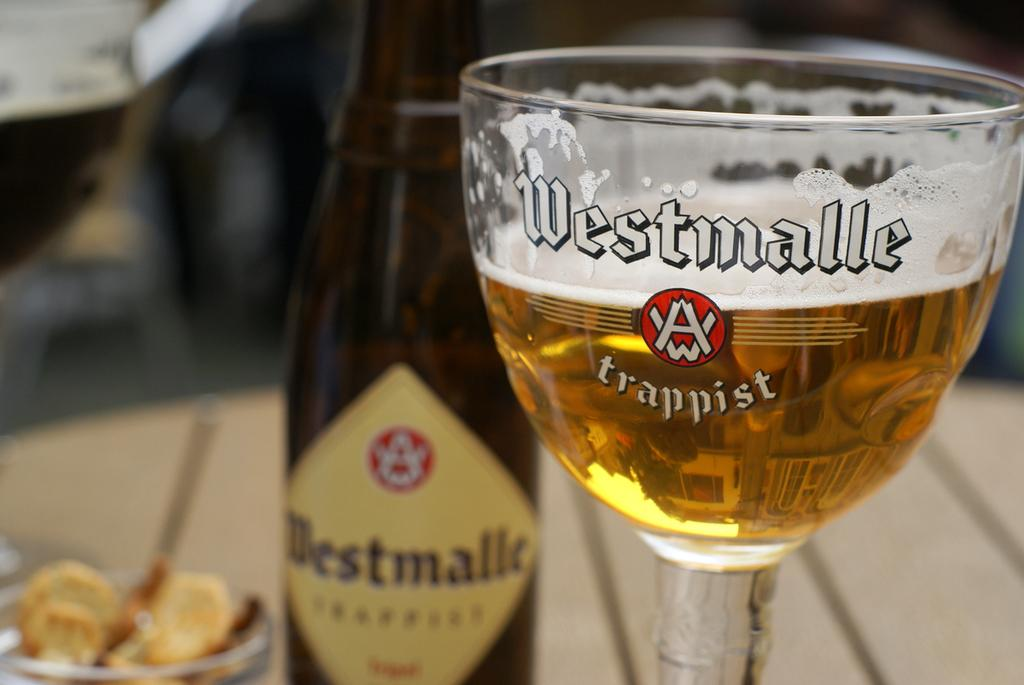<image>
Relay a brief, clear account of the picture shown. A glass of beer has Westmalle Trappist printed on it. 